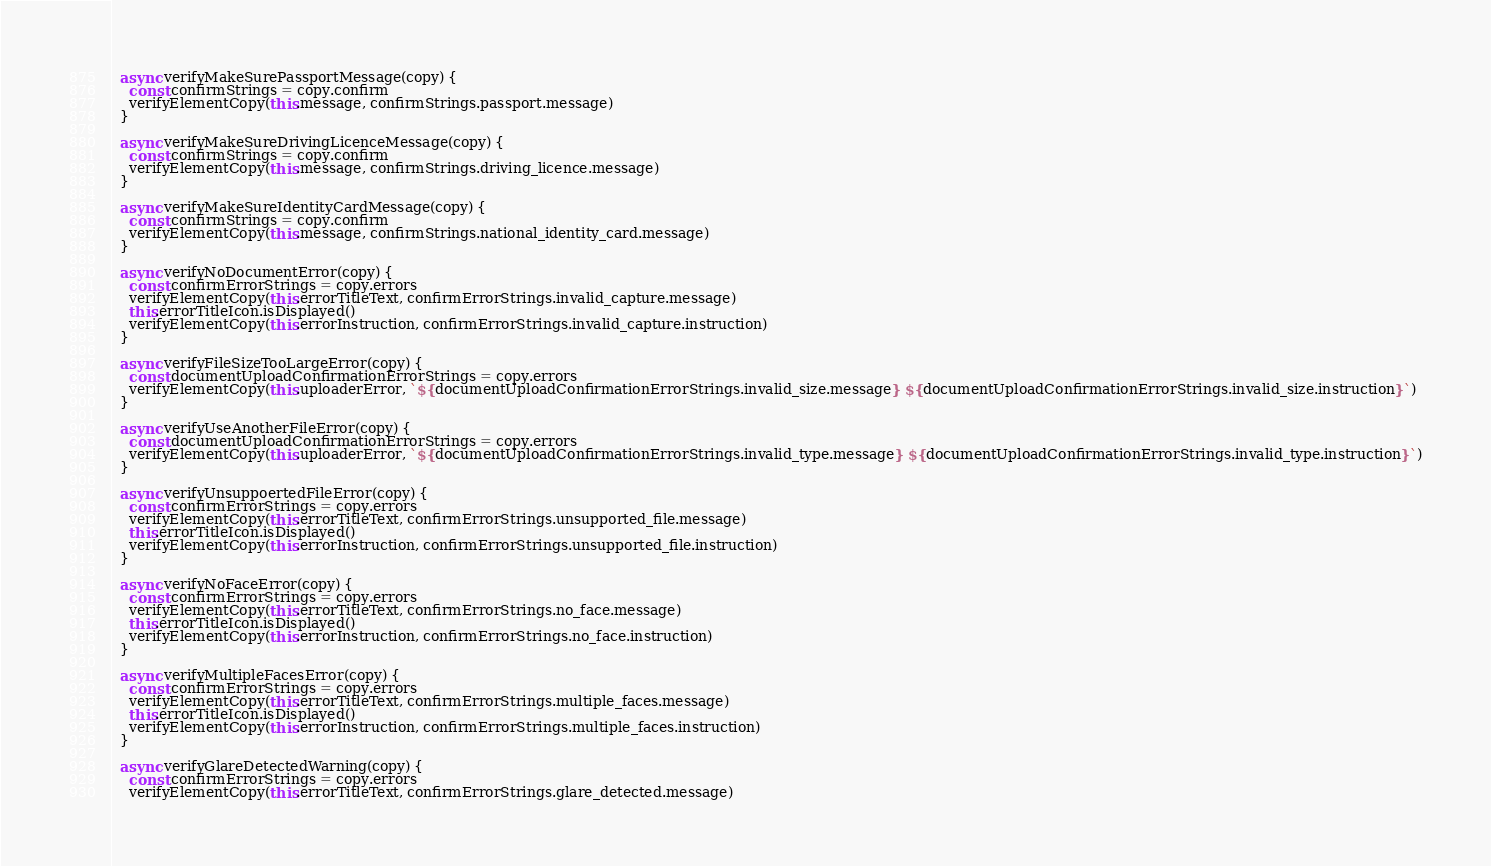<code> <loc_0><loc_0><loc_500><loc_500><_JavaScript_>
  async verifyMakeSurePassportMessage(copy) {
    const confirmStrings = copy.confirm
    verifyElementCopy(this.message, confirmStrings.passport.message)
  }

  async verifyMakeSureDrivingLicenceMessage(copy) {
    const confirmStrings = copy.confirm
    verifyElementCopy(this.message, confirmStrings.driving_licence.message)
  }

  async verifyMakeSureIdentityCardMessage(copy) {
    const confirmStrings = copy.confirm
    verifyElementCopy(this.message, confirmStrings.national_identity_card.message)
  }

  async verifyNoDocumentError(copy) {
    const confirmErrorStrings = copy.errors
    verifyElementCopy(this.errorTitleText, confirmErrorStrings.invalid_capture.message)
    this.errorTitleIcon.isDisplayed()
    verifyElementCopy(this.errorInstruction, confirmErrorStrings.invalid_capture.instruction)
  }

  async verifyFileSizeTooLargeError(copy) {
    const documentUploadConfirmationErrorStrings = copy.errors
    verifyElementCopy(this.uploaderError, `${documentUploadConfirmationErrorStrings.invalid_size.message} ${documentUploadConfirmationErrorStrings.invalid_size.instruction}`)
  }

  async verifyUseAnotherFileError(copy) {
    const documentUploadConfirmationErrorStrings = copy.errors
    verifyElementCopy(this.uploaderError, `${documentUploadConfirmationErrorStrings.invalid_type.message} ${documentUploadConfirmationErrorStrings.invalid_type.instruction}`)
  }

  async verifyUnsuppoertedFileError(copy) {
    const confirmErrorStrings = copy.errors
    verifyElementCopy(this.errorTitleText, confirmErrorStrings.unsupported_file.message)
    this.errorTitleIcon.isDisplayed()
    verifyElementCopy(this.errorInstruction, confirmErrorStrings.unsupported_file.instruction)
  }

  async verifyNoFaceError(copy) {
    const confirmErrorStrings = copy.errors
    verifyElementCopy(this.errorTitleText, confirmErrorStrings.no_face.message)
    this.errorTitleIcon.isDisplayed()
    verifyElementCopy(this.errorInstruction, confirmErrorStrings.no_face.instruction)
  }

  async verifyMultipleFacesError(copy) {
    const confirmErrorStrings = copy.errors
    verifyElementCopy(this.errorTitleText, confirmErrorStrings.multiple_faces.message)
    this.errorTitleIcon.isDisplayed()
    verifyElementCopy(this.errorInstruction, confirmErrorStrings.multiple_faces.instruction)
  }

  async verifyGlareDetectedWarning(copy) {
    const confirmErrorStrings = copy.errors
    verifyElementCopy(this.errorTitleText, confirmErrorStrings.glare_detected.message)</code> 